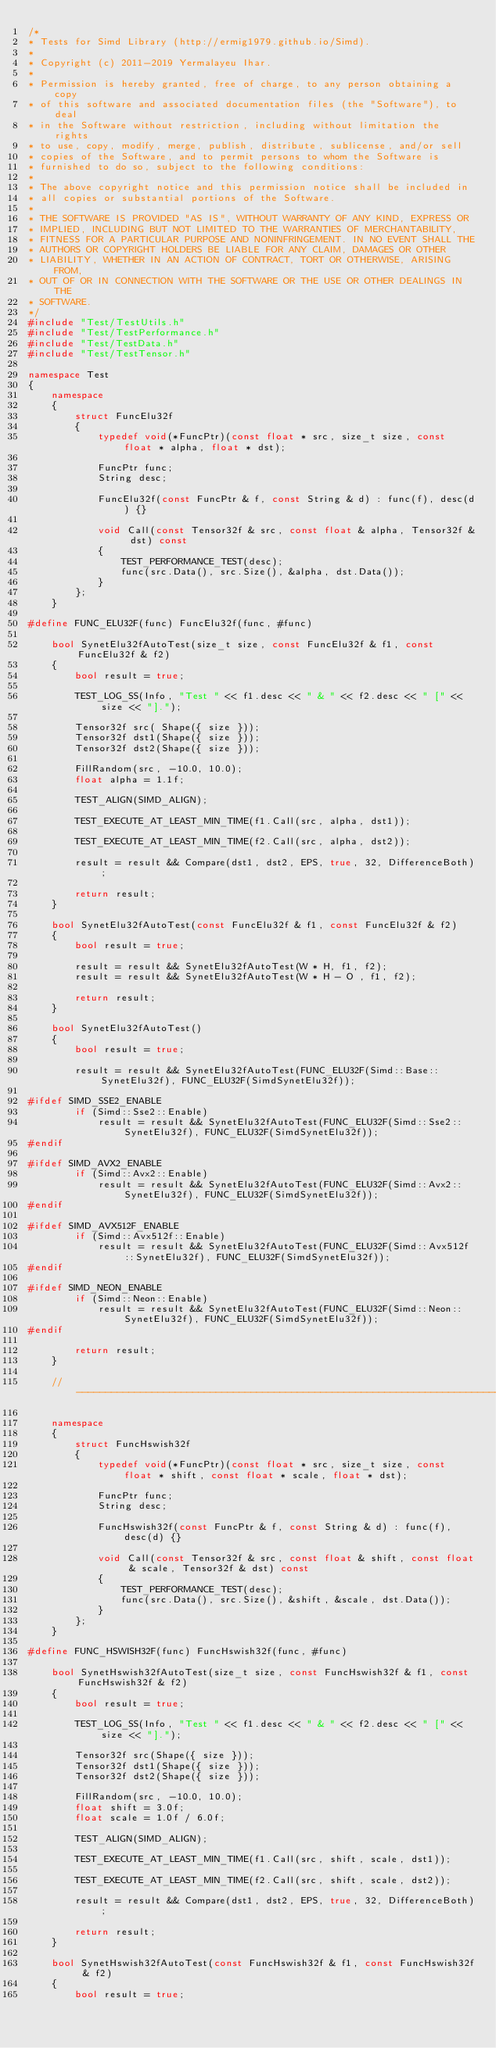<code> <loc_0><loc_0><loc_500><loc_500><_C++_>/*
* Tests for Simd Library (http://ermig1979.github.io/Simd).
*
* Copyright (c) 2011-2019 Yermalayeu Ihar.
*
* Permission is hereby granted, free of charge, to any person obtaining a copy
* of this software and associated documentation files (the "Software"), to deal
* in the Software without restriction, including without limitation the rights
* to use, copy, modify, merge, publish, distribute, sublicense, and/or sell
* copies of the Software, and to permit persons to whom the Software is
* furnished to do so, subject to the following conditions:
*
* The above copyright notice and this permission notice shall be included in
* all copies or substantial portions of the Software.
*
* THE SOFTWARE IS PROVIDED "AS IS", WITHOUT WARRANTY OF ANY KIND, EXPRESS OR
* IMPLIED, INCLUDING BUT NOT LIMITED TO THE WARRANTIES OF MERCHANTABILITY,
* FITNESS FOR A PARTICULAR PURPOSE AND NONINFRINGEMENT. IN NO EVENT SHALL THE
* AUTHORS OR COPYRIGHT HOLDERS BE LIABLE FOR ANY CLAIM, DAMAGES OR OTHER
* LIABILITY, WHETHER IN AN ACTION OF CONTRACT, TORT OR OTHERWISE, ARISING FROM,
* OUT OF OR IN CONNECTION WITH THE SOFTWARE OR THE USE OR OTHER DEALINGS IN THE
* SOFTWARE.
*/
#include "Test/TestUtils.h"
#include "Test/TestPerformance.h"
#include "Test/TestData.h"
#include "Test/TestTensor.h"

namespace Test
{
    namespace
    {
        struct FuncElu32f
        {
            typedef void(*FuncPtr)(const float * src, size_t size, const float * alpha, float * dst);

            FuncPtr func;
            String desc;

            FuncElu32f(const FuncPtr & f, const String & d) : func(f), desc(d) {}

            void Call(const Tensor32f & src, const float & alpha, Tensor32f & dst) const
            {
                TEST_PERFORMANCE_TEST(desc);
                func(src.Data(), src.Size(), &alpha, dst.Data());
            }
        };
    }

#define FUNC_ELU32F(func) FuncElu32f(func, #func)

    bool SynetElu32fAutoTest(size_t size, const FuncElu32f & f1, const FuncElu32f & f2)
    {
        bool result = true;

        TEST_LOG_SS(Info, "Test " << f1.desc << " & " << f2.desc << " [" << size << "].");

        Tensor32f src( Shape({ size }));
        Tensor32f dst1(Shape({ size }));
        Tensor32f dst2(Shape({ size }));

        FillRandom(src, -10.0, 10.0);
        float alpha = 1.1f;

        TEST_ALIGN(SIMD_ALIGN);

        TEST_EXECUTE_AT_LEAST_MIN_TIME(f1.Call(src, alpha, dst1));

        TEST_EXECUTE_AT_LEAST_MIN_TIME(f2.Call(src, alpha, dst2));

        result = result && Compare(dst1, dst2, EPS, true, 32, DifferenceBoth);

        return result;
    }

    bool SynetElu32fAutoTest(const FuncElu32f & f1, const FuncElu32f & f2)
    {
        bool result = true;

        result = result && SynetElu32fAutoTest(W * H, f1, f2);
        result = result && SynetElu32fAutoTest(W * H - O , f1, f2);

        return result;
    }

    bool SynetElu32fAutoTest()
    {
        bool result = true;

        result = result && SynetElu32fAutoTest(FUNC_ELU32F(Simd::Base::SynetElu32f), FUNC_ELU32F(SimdSynetElu32f));

#ifdef SIMD_SSE2_ENABLE
        if (Simd::Sse2::Enable)
            result = result && SynetElu32fAutoTest(FUNC_ELU32F(Simd::Sse2::SynetElu32f), FUNC_ELU32F(SimdSynetElu32f));
#endif 

#ifdef SIMD_AVX2_ENABLE
        if (Simd::Avx2::Enable)
            result = result && SynetElu32fAutoTest(FUNC_ELU32F(Simd::Avx2::SynetElu32f), FUNC_ELU32F(SimdSynetElu32f));
#endif 

#ifdef SIMD_AVX512F_ENABLE
        if (Simd::Avx512f::Enable)
            result = result && SynetElu32fAutoTest(FUNC_ELU32F(Simd::Avx512f::SynetElu32f), FUNC_ELU32F(SimdSynetElu32f));
#endif 

#ifdef SIMD_NEON_ENABLE
        if (Simd::Neon::Enable)
            result = result && SynetElu32fAutoTest(FUNC_ELU32F(Simd::Neon::SynetElu32f), FUNC_ELU32F(SimdSynetElu32f));
#endif 

        return result;
    }

    //-------------------------------------------------------------------------

    namespace
    {
        struct FuncHswish32f
        {
            typedef void(*FuncPtr)(const float * src, size_t size, const float * shift, const float * scale, float * dst);

            FuncPtr func;
            String desc;

            FuncHswish32f(const FuncPtr & f, const String & d) : func(f), desc(d) {}

            void Call(const Tensor32f & src, const float & shift, const float & scale, Tensor32f & dst) const
            {
                TEST_PERFORMANCE_TEST(desc);
                func(src.Data(), src.Size(), &shift, &scale, dst.Data());
            }
        };
    }

#define FUNC_HSWISH32F(func) FuncHswish32f(func, #func)

    bool SynetHswish32fAutoTest(size_t size, const FuncHswish32f & f1, const FuncHswish32f & f2)
    {
        bool result = true;

        TEST_LOG_SS(Info, "Test " << f1.desc << " & " << f2.desc << " [" << size << "].");

        Tensor32f src(Shape({ size }));
        Tensor32f dst1(Shape({ size }));
        Tensor32f dst2(Shape({ size }));

        FillRandom(src, -10.0, 10.0);
        float shift = 3.0f;
        float scale = 1.0f / 6.0f;

        TEST_ALIGN(SIMD_ALIGN);

        TEST_EXECUTE_AT_LEAST_MIN_TIME(f1.Call(src, shift, scale, dst1));

        TEST_EXECUTE_AT_LEAST_MIN_TIME(f2.Call(src, shift, scale, dst2));

        result = result && Compare(dst1, dst2, EPS, true, 32, DifferenceBoth);

        return result;
    }

    bool SynetHswish32fAutoTest(const FuncHswish32f & f1, const FuncHswish32f & f2)
    {
        bool result = true;
</code> 